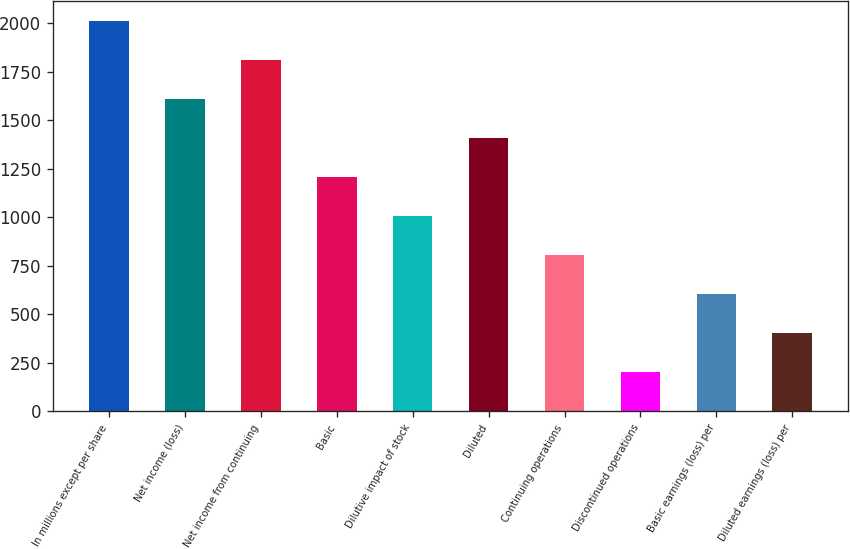Convert chart to OTSL. <chart><loc_0><loc_0><loc_500><loc_500><bar_chart><fcel>In millions except per share<fcel>Net income (loss)<fcel>Net income from continuing<fcel>Basic<fcel>Dilutive impact of stock<fcel>Diluted<fcel>Continuing operations<fcel>Discontinued operations<fcel>Basic earnings (loss) per<fcel>Diluted earnings (loss) per<nl><fcel>2014<fcel>1611.3<fcel>1812.65<fcel>1208.6<fcel>1007.25<fcel>1409.95<fcel>805.9<fcel>201.85<fcel>604.55<fcel>403.2<nl></chart> 